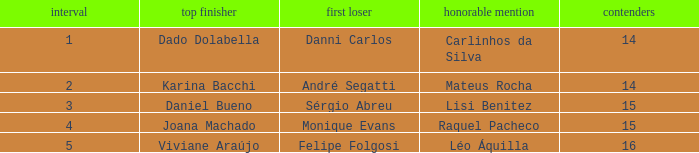In what season was the winner Dado Dolabella? 1.0. 